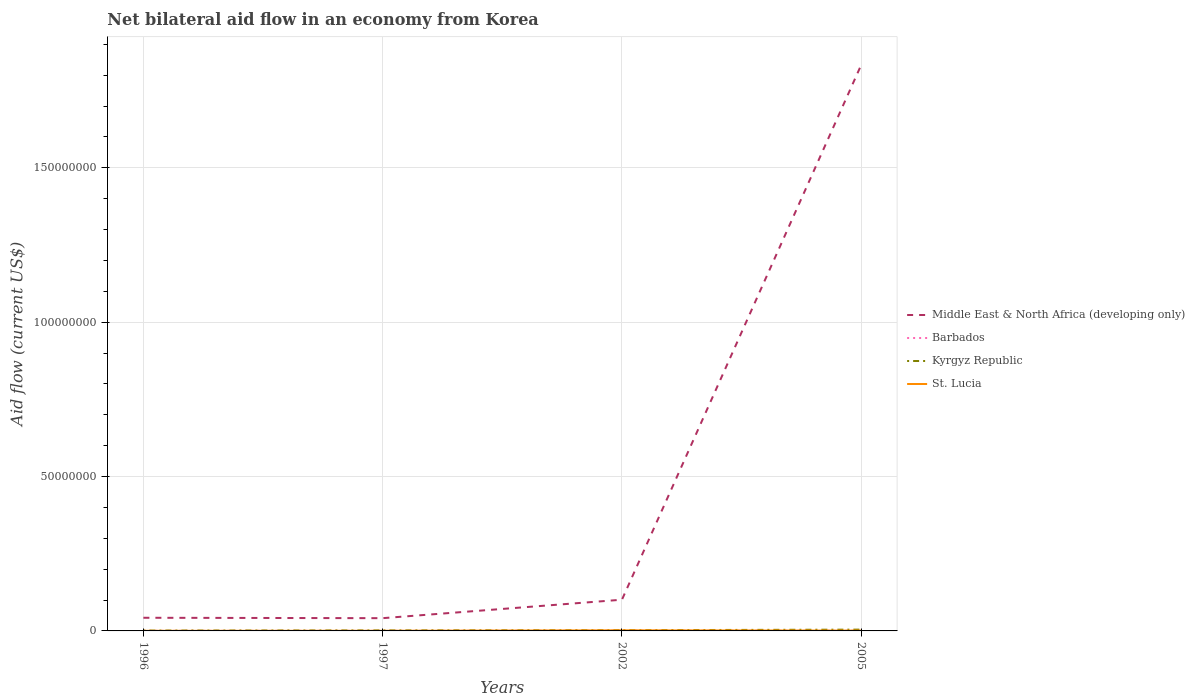How many different coloured lines are there?
Your answer should be very brief. 4. Does the line corresponding to Barbados intersect with the line corresponding to Kyrgyz Republic?
Make the answer very short. No. Is the number of lines equal to the number of legend labels?
Ensure brevity in your answer.  Yes. Across all years, what is the maximum net bilateral aid flow in Middle East & North Africa (developing only)?
Provide a short and direct response. 4.13e+06. What is the total net bilateral aid flow in Kyrgyz Republic in the graph?
Offer a very short reply. -7.00e+04. What is the difference between the highest and the lowest net bilateral aid flow in Barbados?
Offer a very short reply. 2. How many years are there in the graph?
Ensure brevity in your answer.  4. What is the difference between two consecutive major ticks on the Y-axis?
Provide a short and direct response. 5.00e+07. Does the graph contain grids?
Provide a succinct answer. Yes. What is the title of the graph?
Your answer should be compact. Net bilateral aid flow in an economy from Korea. What is the label or title of the Y-axis?
Give a very brief answer. Aid flow (current US$). What is the Aid flow (current US$) in Middle East & North Africa (developing only) in 1996?
Give a very brief answer. 4.26e+06. What is the Aid flow (current US$) in Middle East & North Africa (developing only) in 1997?
Offer a very short reply. 4.13e+06. What is the Aid flow (current US$) of Barbados in 1997?
Your response must be concise. 2.00e+04. What is the Aid flow (current US$) in Kyrgyz Republic in 1997?
Your answer should be compact. 1.60e+05. What is the Aid flow (current US$) of Middle East & North Africa (developing only) in 2002?
Your response must be concise. 1.01e+07. What is the Aid flow (current US$) in Barbados in 2002?
Your answer should be compact. 9.00e+04. What is the Aid flow (current US$) in St. Lucia in 2002?
Provide a short and direct response. 1.90e+05. What is the Aid flow (current US$) of Middle East & North Africa (developing only) in 2005?
Provide a succinct answer. 1.83e+08. What is the Aid flow (current US$) in Barbados in 2005?
Provide a short and direct response. 5.00e+04. What is the Aid flow (current US$) in Kyrgyz Republic in 2005?
Provide a short and direct response. 4.20e+05. What is the Aid flow (current US$) in St. Lucia in 2005?
Provide a short and direct response. 1.00e+05. Across all years, what is the maximum Aid flow (current US$) of Middle East & North Africa (developing only)?
Your response must be concise. 1.83e+08. Across all years, what is the maximum Aid flow (current US$) of Kyrgyz Republic?
Ensure brevity in your answer.  4.20e+05. Across all years, what is the minimum Aid flow (current US$) of Middle East & North Africa (developing only)?
Offer a terse response. 4.13e+06. Across all years, what is the minimum Aid flow (current US$) in Barbados?
Provide a succinct answer. 2.00e+04. Across all years, what is the minimum Aid flow (current US$) of St. Lucia?
Your response must be concise. 3.00e+04. What is the total Aid flow (current US$) in Middle East & North Africa (developing only) in the graph?
Provide a succinct answer. 2.02e+08. What is the total Aid flow (current US$) of Kyrgyz Republic in the graph?
Your response must be concise. 9.20e+05. What is the total Aid flow (current US$) in St. Lucia in the graph?
Make the answer very short. 3.60e+05. What is the difference between the Aid flow (current US$) in Middle East & North Africa (developing only) in 1996 and that in 1997?
Keep it short and to the point. 1.30e+05. What is the difference between the Aid flow (current US$) of Barbados in 1996 and that in 1997?
Provide a short and direct response. 10000. What is the difference between the Aid flow (current US$) of Middle East & North Africa (developing only) in 1996 and that in 2002?
Ensure brevity in your answer.  -5.85e+06. What is the difference between the Aid flow (current US$) of Barbados in 1996 and that in 2002?
Ensure brevity in your answer.  -6.00e+04. What is the difference between the Aid flow (current US$) in Kyrgyz Republic in 1996 and that in 2002?
Make the answer very short. -1.20e+05. What is the difference between the Aid flow (current US$) of Middle East & North Africa (developing only) in 1996 and that in 2005?
Your answer should be very brief. -1.79e+08. What is the difference between the Aid flow (current US$) in Barbados in 1996 and that in 2005?
Provide a succinct answer. -2.00e+04. What is the difference between the Aid flow (current US$) of Kyrgyz Republic in 1996 and that in 2005?
Provide a short and direct response. -3.10e+05. What is the difference between the Aid flow (current US$) in Middle East & North Africa (developing only) in 1997 and that in 2002?
Provide a short and direct response. -5.98e+06. What is the difference between the Aid flow (current US$) of Barbados in 1997 and that in 2002?
Offer a terse response. -7.00e+04. What is the difference between the Aid flow (current US$) of St. Lucia in 1997 and that in 2002?
Make the answer very short. -1.50e+05. What is the difference between the Aid flow (current US$) of Middle East & North Africa (developing only) in 1997 and that in 2005?
Keep it short and to the point. -1.79e+08. What is the difference between the Aid flow (current US$) of St. Lucia in 1997 and that in 2005?
Make the answer very short. -6.00e+04. What is the difference between the Aid flow (current US$) in Middle East & North Africa (developing only) in 2002 and that in 2005?
Provide a short and direct response. -1.73e+08. What is the difference between the Aid flow (current US$) of Kyrgyz Republic in 2002 and that in 2005?
Make the answer very short. -1.90e+05. What is the difference between the Aid flow (current US$) in Middle East & North Africa (developing only) in 1996 and the Aid flow (current US$) in Barbados in 1997?
Offer a very short reply. 4.24e+06. What is the difference between the Aid flow (current US$) in Middle East & North Africa (developing only) in 1996 and the Aid flow (current US$) in Kyrgyz Republic in 1997?
Your response must be concise. 4.10e+06. What is the difference between the Aid flow (current US$) in Middle East & North Africa (developing only) in 1996 and the Aid flow (current US$) in St. Lucia in 1997?
Offer a terse response. 4.22e+06. What is the difference between the Aid flow (current US$) in Barbados in 1996 and the Aid flow (current US$) in St. Lucia in 1997?
Your response must be concise. -10000. What is the difference between the Aid flow (current US$) of Kyrgyz Republic in 1996 and the Aid flow (current US$) of St. Lucia in 1997?
Provide a short and direct response. 7.00e+04. What is the difference between the Aid flow (current US$) of Middle East & North Africa (developing only) in 1996 and the Aid flow (current US$) of Barbados in 2002?
Your answer should be very brief. 4.17e+06. What is the difference between the Aid flow (current US$) in Middle East & North Africa (developing only) in 1996 and the Aid flow (current US$) in Kyrgyz Republic in 2002?
Your response must be concise. 4.03e+06. What is the difference between the Aid flow (current US$) in Middle East & North Africa (developing only) in 1996 and the Aid flow (current US$) in St. Lucia in 2002?
Offer a very short reply. 4.07e+06. What is the difference between the Aid flow (current US$) of Barbados in 1996 and the Aid flow (current US$) of Kyrgyz Republic in 2002?
Provide a succinct answer. -2.00e+05. What is the difference between the Aid flow (current US$) of Barbados in 1996 and the Aid flow (current US$) of St. Lucia in 2002?
Offer a terse response. -1.60e+05. What is the difference between the Aid flow (current US$) in Kyrgyz Republic in 1996 and the Aid flow (current US$) in St. Lucia in 2002?
Ensure brevity in your answer.  -8.00e+04. What is the difference between the Aid flow (current US$) in Middle East & North Africa (developing only) in 1996 and the Aid flow (current US$) in Barbados in 2005?
Give a very brief answer. 4.21e+06. What is the difference between the Aid flow (current US$) of Middle East & North Africa (developing only) in 1996 and the Aid flow (current US$) of Kyrgyz Republic in 2005?
Your answer should be compact. 3.84e+06. What is the difference between the Aid flow (current US$) in Middle East & North Africa (developing only) in 1996 and the Aid flow (current US$) in St. Lucia in 2005?
Provide a short and direct response. 4.16e+06. What is the difference between the Aid flow (current US$) of Barbados in 1996 and the Aid flow (current US$) of Kyrgyz Republic in 2005?
Provide a succinct answer. -3.90e+05. What is the difference between the Aid flow (current US$) of Barbados in 1996 and the Aid flow (current US$) of St. Lucia in 2005?
Provide a succinct answer. -7.00e+04. What is the difference between the Aid flow (current US$) in Middle East & North Africa (developing only) in 1997 and the Aid flow (current US$) in Barbados in 2002?
Ensure brevity in your answer.  4.04e+06. What is the difference between the Aid flow (current US$) of Middle East & North Africa (developing only) in 1997 and the Aid flow (current US$) of Kyrgyz Republic in 2002?
Keep it short and to the point. 3.90e+06. What is the difference between the Aid flow (current US$) in Middle East & North Africa (developing only) in 1997 and the Aid flow (current US$) in St. Lucia in 2002?
Make the answer very short. 3.94e+06. What is the difference between the Aid flow (current US$) in Barbados in 1997 and the Aid flow (current US$) in Kyrgyz Republic in 2002?
Provide a succinct answer. -2.10e+05. What is the difference between the Aid flow (current US$) in Kyrgyz Republic in 1997 and the Aid flow (current US$) in St. Lucia in 2002?
Offer a terse response. -3.00e+04. What is the difference between the Aid flow (current US$) of Middle East & North Africa (developing only) in 1997 and the Aid flow (current US$) of Barbados in 2005?
Make the answer very short. 4.08e+06. What is the difference between the Aid flow (current US$) of Middle East & North Africa (developing only) in 1997 and the Aid flow (current US$) of Kyrgyz Republic in 2005?
Offer a very short reply. 3.71e+06. What is the difference between the Aid flow (current US$) in Middle East & North Africa (developing only) in 1997 and the Aid flow (current US$) in St. Lucia in 2005?
Ensure brevity in your answer.  4.03e+06. What is the difference between the Aid flow (current US$) of Barbados in 1997 and the Aid flow (current US$) of Kyrgyz Republic in 2005?
Keep it short and to the point. -4.00e+05. What is the difference between the Aid flow (current US$) in Barbados in 1997 and the Aid flow (current US$) in St. Lucia in 2005?
Make the answer very short. -8.00e+04. What is the difference between the Aid flow (current US$) in Kyrgyz Republic in 1997 and the Aid flow (current US$) in St. Lucia in 2005?
Keep it short and to the point. 6.00e+04. What is the difference between the Aid flow (current US$) in Middle East & North Africa (developing only) in 2002 and the Aid flow (current US$) in Barbados in 2005?
Give a very brief answer. 1.01e+07. What is the difference between the Aid flow (current US$) of Middle East & North Africa (developing only) in 2002 and the Aid flow (current US$) of Kyrgyz Republic in 2005?
Your answer should be compact. 9.69e+06. What is the difference between the Aid flow (current US$) in Middle East & North Africa (developing only) in 2002 and the Aid flow (current US$) in St. Lucia in 2005?
Provide a succinct answer. 1.00e+07. What is the difference between the Aid flow (current US$) of Barbados in 2002 and the Aid flow (current US$) of Kyrgyz Republic in 2005?
Ensure brevity in your answer.  -3.30e+05. What is the average Aid flow (current US$) of Middle East & North Africa (developing only) per year?
Your answer should be very brief. 5.05e+07. What is the average Aid flow (current US$) in Barbados per year?
Your response must be concise. 4.75e+04. What is the average Aid flow (current US$) in Kyrgyz Republic per year?
Offer a very short reply. 2.30e+05. What is the average Aid flow (current US$) of St. Lucia per year?
Your response must be concise. 9.00e+04. In the year 1996, what is the difference between the Aid flow (current US$) in Middle East & North Africa (developing only) and Aid flow (current US$) in Barbados?
Your answer should be compact. 4.23e+06. In the year 1996, what is the difference between the Aid flow (current US$) of Middle East & North Africa (developing only) and Aid flow (current US$) of Kyrgyz Republic?
Keep it short and to the point. 4.15e+06. In the year 1996, what is the difference between the Aid flow (current US$) in Middle East & North Africa (developing only) and Aid flow (current US$) in St. Lucia?
Your answer should be compact. 4.23e+06. In the year 1996, what is the difference between the Aid flow (current US$) of Kyrgyz Republic and Aid flow (current US$) of St. Lucia?
Your answer should be very brief. 8.00e+04. In the year 1997, what is the difference between the Aid flow (current US$) in Middle East & North Africa (developing only) and Aid flow (current US$) in Barbados?
Your answer should be very brief. 4.11e+06. In the year 1997, what is the difference between the Aid flow (current US$) of Middle East & North Africa (developing only) and Aid flow (current US$) of Kyrgyz Republic?
Your answer should be compact. 3.97e+06. In the year 1997, what is the difference between the Aid flow (current US$) in Middle East & North Africa (developing only) and Aid flow (current US$) in St. Lucia?
Offer a very short reply. 4.09e+06. In the year 1997, what is the difference between the Aid flow (current US$) in Barbados and Aid flow (current US$) in Kyrgyz Republic?
Keep it short and to the point. -1.40e+05. In the year 2002, what is the difference between the Aid flow (current US$) in Middle East & North Africa (developing only) and Aid flow (current US$) in Barbados?
Give a very brief answer. 1.00e+07. In the year 2002, what is the difference between the Aid flow (current US$) of Middle East & North Africa (developing only) and Aid flow (current US$) of Kyrgyz Republic?
Ensure brevity in your answer.  9.88e+06. In the year 2002, what is the difference between the Aid flow (current US$) in Middle East & North Africa (developing only) and Aid flow (current US$) in St. Lucia?
Keep it short and to the point. 9.92e+06. In the year 2002, what is the difference between the Aid flow (current US$) in Barbados and Aid flow (current US$) in Kyrgyz Republic?
Keep it short and to the point. -1.40e+05. In the year 2002, what is the difference between the Aid flow (current US$) of Barbados and Aid flow (current US$) of St. Lucia?
Provide a succinct answer. -1.00e+05. In the year 2002, what is the difference between the Aid flow (current US$) in Kyrgyz Republic and Aid flow (current US$) in St. Lucia?
Provide a succinct answer. 4.00e+04. In the year 2005, what is the difference between the Aid flow (current US$) of Middle East & North Africa (developing only) and Aid flow (current US$) of Barbados?
Your answer should be compact. 1.83e+08. In the year 2005, what is the difference between the Aid flow (current US$) of Middle East & North Africa (developing only) and Aid flow (current US$) of Kyrgyz Republic?
Make the answer very short. 1.83e+08. In the year 2005, what is the difference between the Aid flow (current US$) in Middle East & North Africa (developing only) and Aid flow (current US$) in St. Lucia?
Keep it short and to the point. 1.83e+08. In the year 2005, what is the difference between the Aid flow (current US$) in Barbados and Aid flow (current US$) in Kyrgyz Republic?
Provide a succinct answer. -3.70e+05. In the year 2005, what is the difference between the Aid flow (current US$) of Barbados and Aid flow (current US$) of St. Lucia?
Offer a very short reply. -5.00e+04. What is the ratio of the Aid flow (current US$) of Middle East & North Africa (developing only) in 1996 to that in 1997?
Your answer should be very brief. 1.03. What is the ratio of the Aid flow (current US$) of Barbados in 1996 to that in 1997?
Make the answer very short. 1.5. What is the ratio of the Aid flow (current US$) in Kyrgyz Republic in 1996 to that in 1997?
Your answer should be compact. 0.69. What is the ratio of the Aid flow (current US$) of St. Lucia in 1996 to that in 1997?
Keep it short and to the point. 0.75. What is the ratio of the Aid flow (current US$) in Middle East & North Africa (developing only) in 1996 to that in 2002?
Provide a succinct answer. 0.42. What is the ratio of the Aid flow (current US$) of Barbados in 1996 to that in 2002?
Make the answer very short. 0.33. What is the ratio of the Aid flow (current US$) in Kyrgyz Republic in 1996 to that in 2002?
Your answer should be compact. 0.48. What is the ratio of the Aid flow (current US$) in St. Lucia in 1996 to that in 2002?
Ensure brevity in your answer.  0.16. What is the ratio of the Aid flow (current US$) in Middle East & North Africa (developing only) in 1996 to that in 2005?
Your answer should be compact. 0.02. What is the ratio of the Aid flow (current US$) of Barbados in 1996 to that in 2005?
Ensure brevity in your answer.  0.6. What is the ratio of the Aid flow (current US$) of Kyrgyz Republic in 1996 to that in 2005?
Provide a short and direct response. 0.26. What is the ratio of the Aid flow (current US$) in Middle East & North Africa (developing only) in 1997 to that in 2002?
Give a very brief answer. 0.41. What is the ratio of the Aid flow (current US$) in Barbados in 1997 to that in 2002?
Provide a short and direct response. 0.22. What is the ratio of the Aid flow (current US$) in Kyrgyz Republic in 1997 to that in 2002?
Give a very brief answer. 0.7. What is the ratio of the Aid flow (current US$) in St. Lucia in 1997 to that in 2002?
Provide a succinct answer. 0.21. What is the ratio of the Aid flow (current US$) in Middle East & North Africa (developing only) in 1997 to that in 2005?
Your answer should be compact. 0.02. What is the ratio of the Aid flow (current US$) in Barbados in 1997 to that in 2005?
Keep it short and to the point. 0.4. What is the ratio of the Aid flow (current US$) in Kyrgyz Republic in 1997 to that in 2005?
Provide a short and direct response. 0.38. What is the ratio of the Aid flow (current US$) in St. Lucia in 1997 to that in 2005?
Make the answer very short. 0.4. What is the ratio of the Aid flow (current US$) of Middle East & North Africa (developing only) in 2002 to that in 2005?
Your answer should be compact. 0.06. What is the ratio of the Aid flow (current US$) of Barbados in 2002 to that in 2005?
Ensure brevity in your answer.  1.8. What is the ratio of the Aid flow (current US$) of Kyrgyz Republic in 2002 to that in 2005?
Give a very brief answer. 0.55. What is the ratio of the Aid flow (current US$) in St. Lucia in 2002 to that in 2005?
Provide a succinct answer. 1.9. What is the difference between the highest and the second highest Aid flow (current US$) of Middle East & North Africa (developing only)?
Offer a terse response. 1.73e+08. What is the difference between the highest and the second highest Aid flow (current US$) of St. Lucia?
Provide a short and direct response. 9.00e+04. What is the difference between the highest and the lowest Aid flow (current US$) in Middle East & North Africa (developing only)?
Keep it short and to the point. 1.79e+08. What is the difference between the highest and the lowest Aid flow (current US$) of Kyrgyz Republic?
Keep it short and to the point. 3.10e+05. 